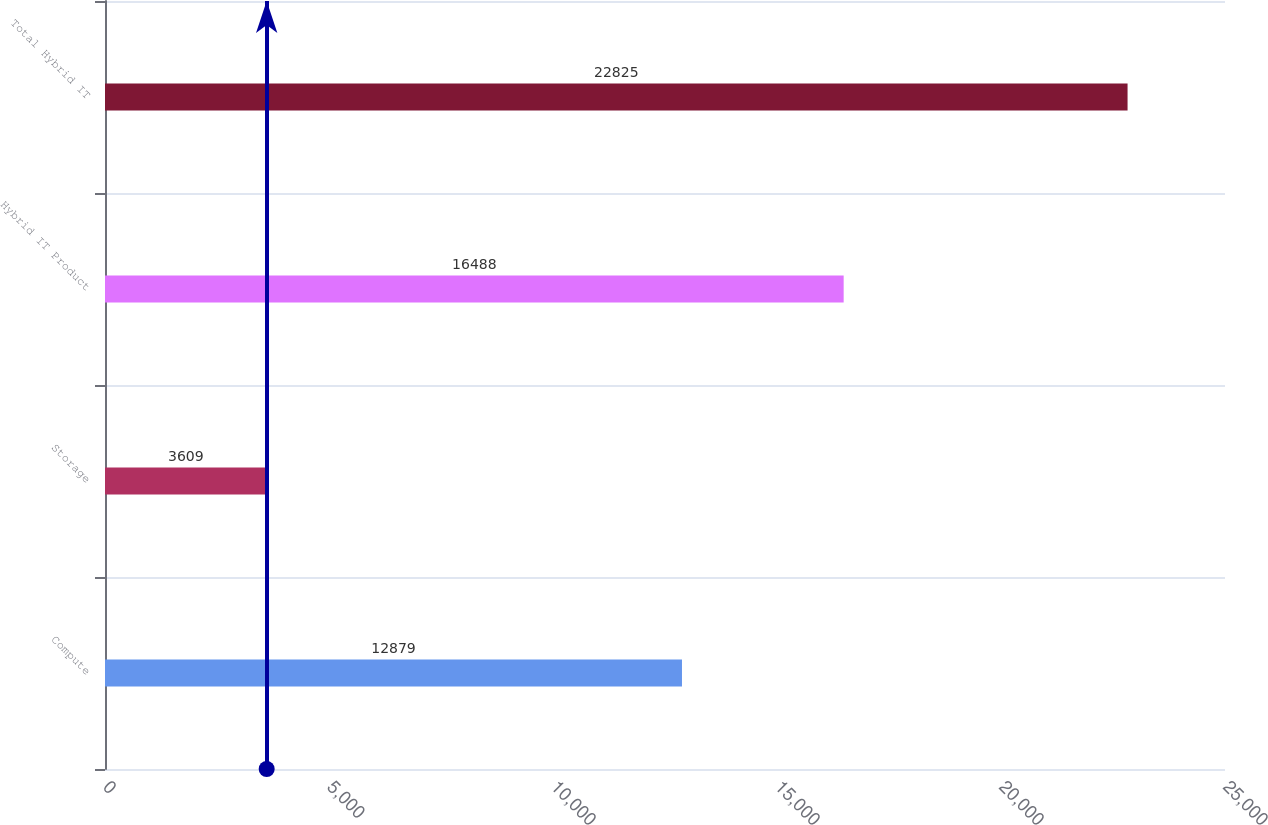Convert chart. <chart><loc_0><loc_0><loc_500><loc_500><bar_chart><fcel>Compute<fcel>Storage<fcel>Hybrid IT Product<fcel>Total Hybrid IT<nl><fcel>12879<fcel>3609<fcel>16488<fcel>22825<nl></chart> 